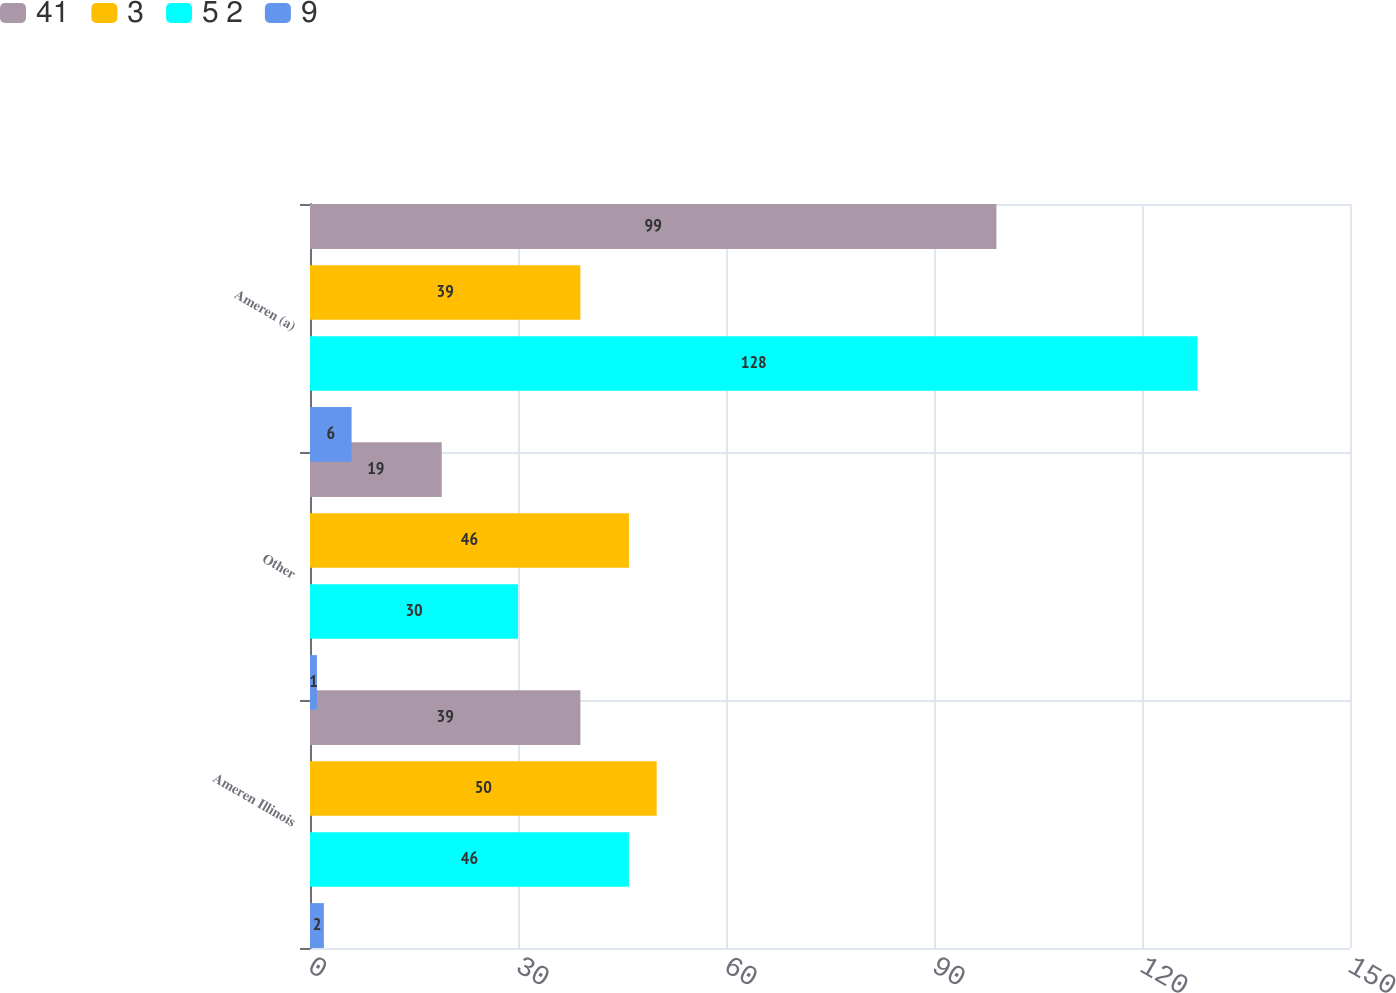Convert chart. <chart><loc_0><loc_0><loc_500><loc_500><stacked_bar_chart><ecel><fcel>Ameren Illinois<fcel>Other<fcel>Ameren (a)<nl><fcel>41<fcel>39<fcel>19<fcel>99<nl><fcel>3<fcel>50<fcel>46<fcel>39<nl><fcel>5 2<fcel>46<fcel>30<fcel>128<nl><fcel>9<fcel>2<fcel>1<fcel>6<nl></chart> 